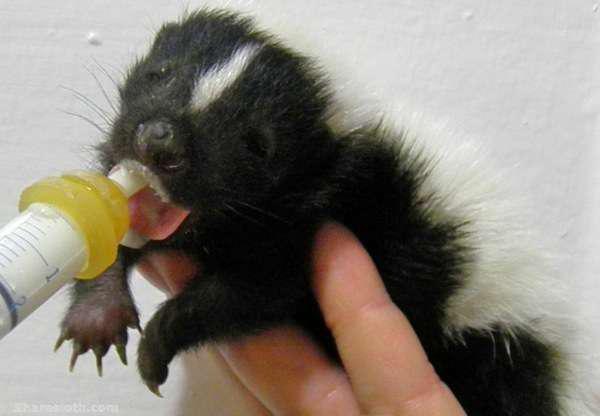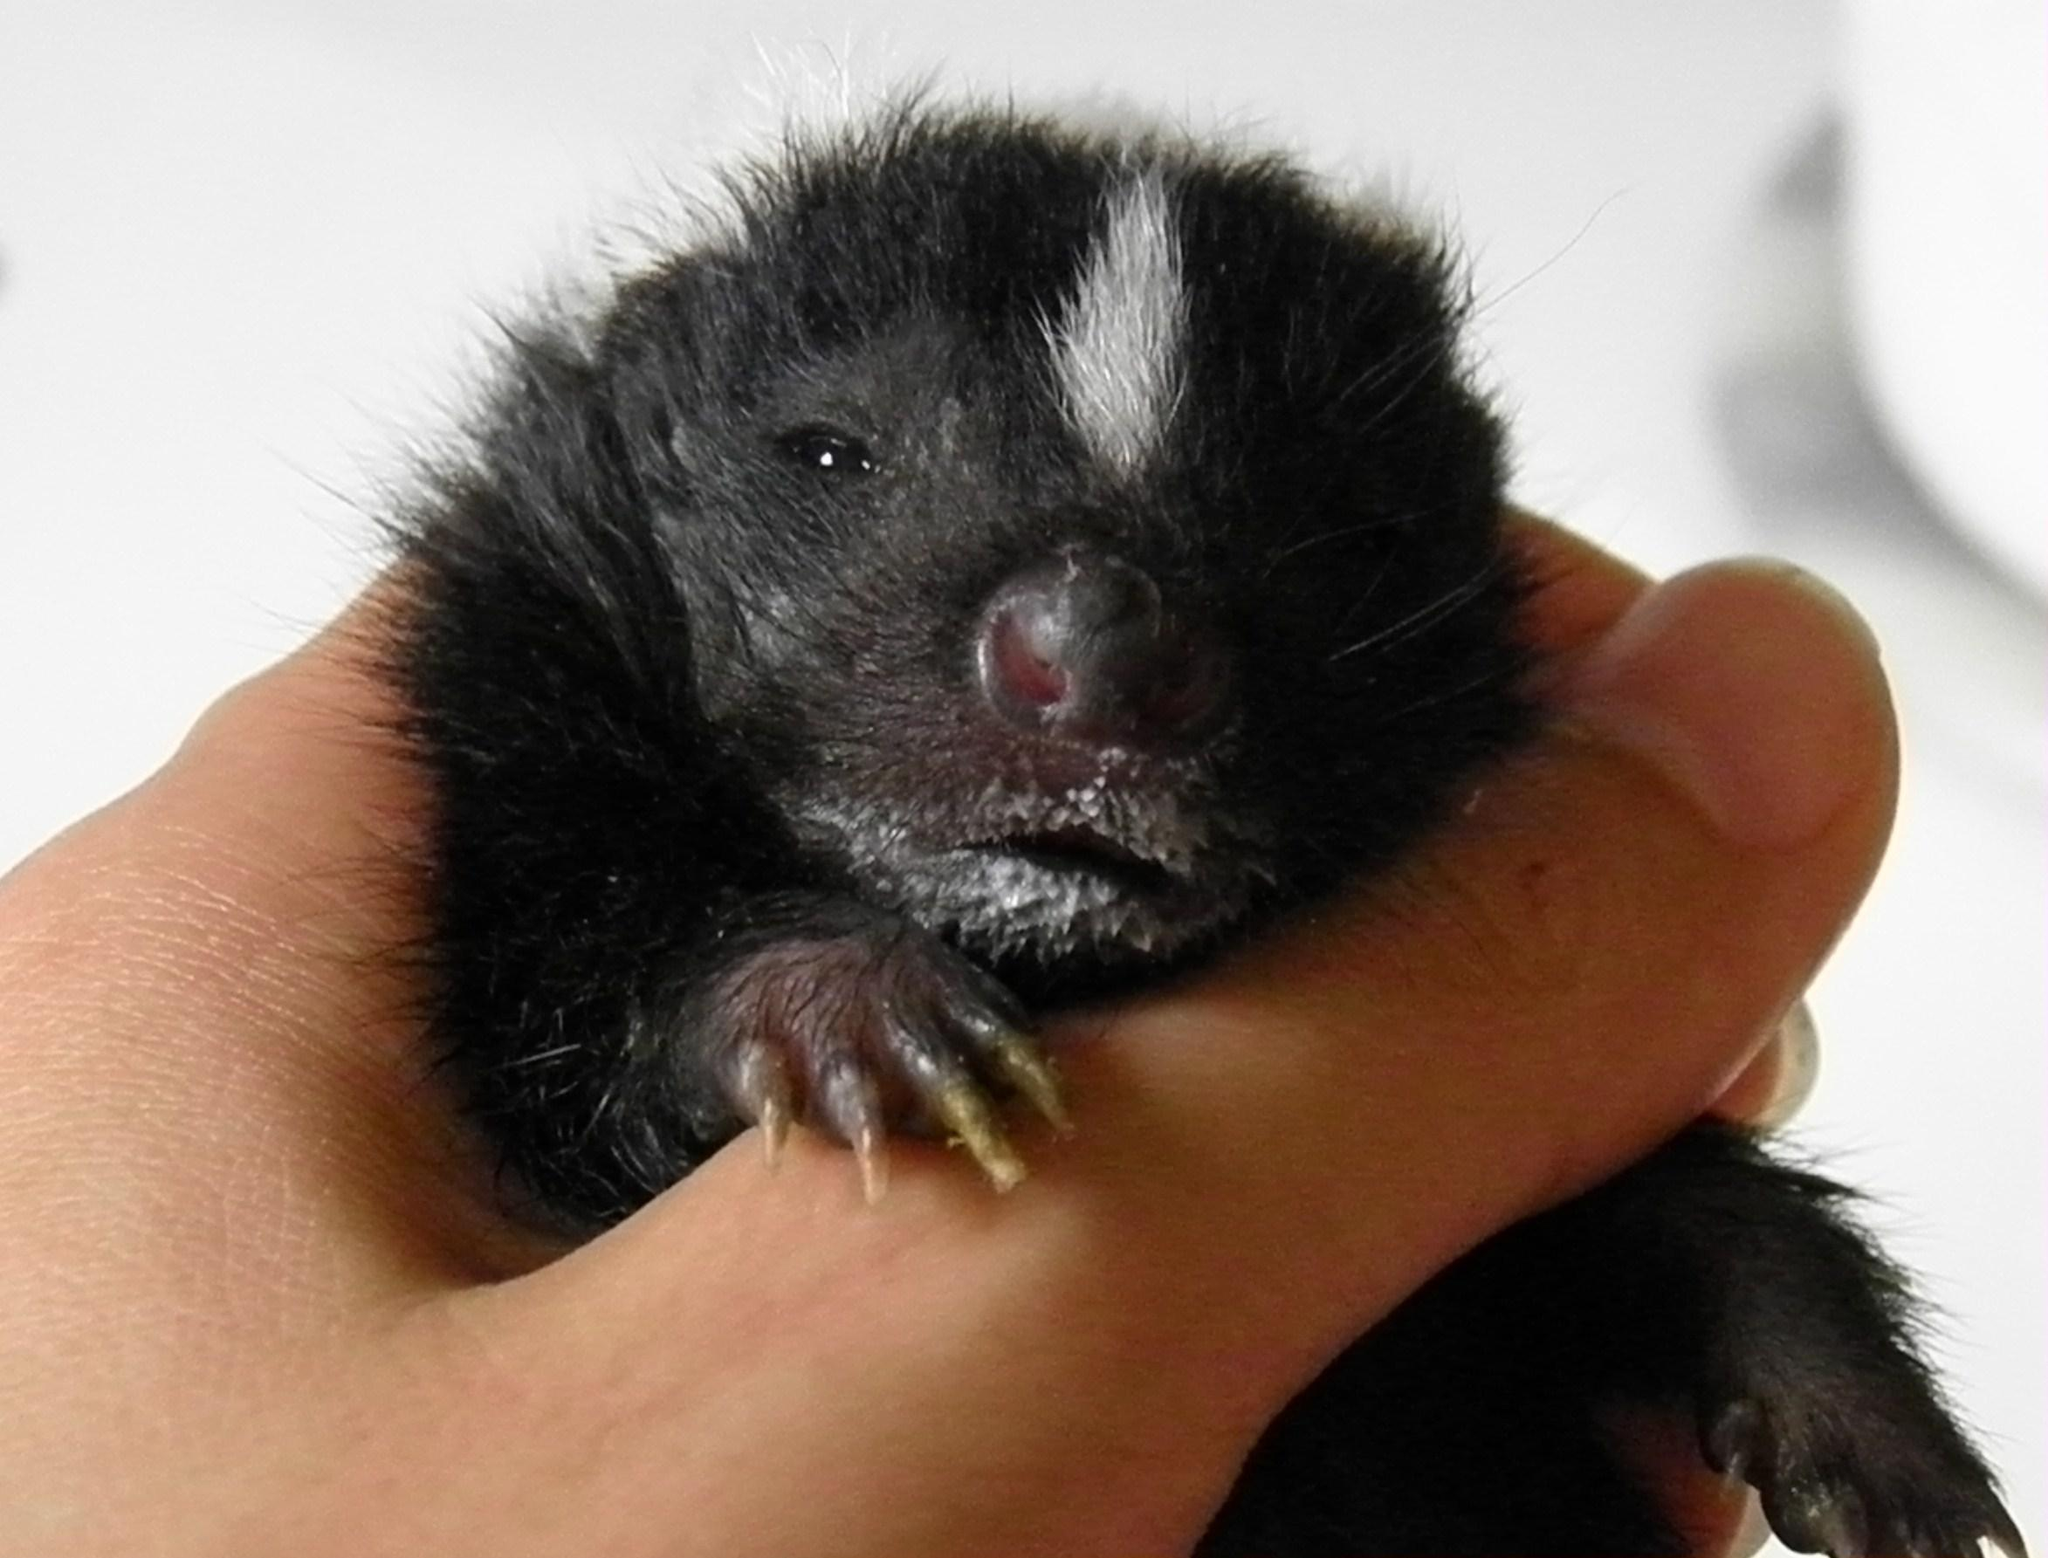The first image is the image on the left, the second image is the image on the right. Evaluate the accuracy of this statement regarding the images: "One image features a hand holding up a leftward-turned baby skunk, which is feeding from a syringe.". Is it true? Answer yes or no. Yes. The first image is the image on the left, the second image is the image on the right. Examine the images to the left and right. Is the description "The skunk in the right image is being bottle fed." accurate? Answer yes or no. No. 